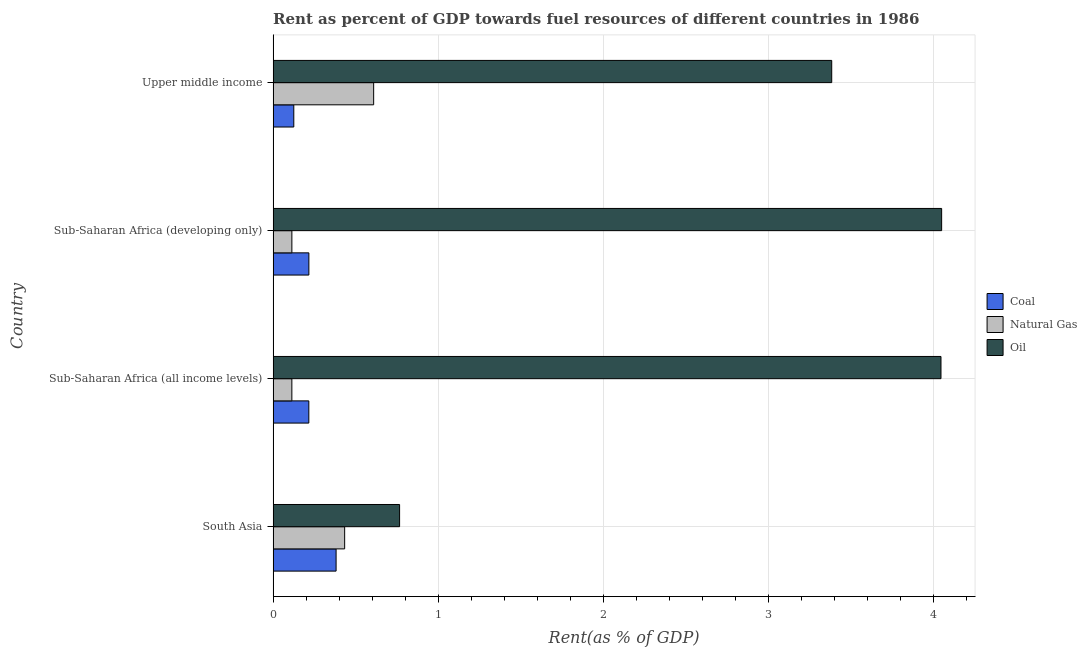How many different coloured bars are there?
Give a very brief answer. 3. Are the number of bars on each tick of the Y-axis equal?
Your answer should be compact. Yes. How many bars are there on the 1st tick from the top?
Your response must be concise. 3. How many bars are there on the 3rd tick from the bottom?
Provide a succinct answer. 3. What is the label of the 3rd group of bars from the top?
Your response must be concise. Sub-Saharan Africa (all income levels). In how many cases, is the number of bars for a given country not equal to the number of legend labels?
Keep it short and to the point. 0. What is the rent towards coal in Sub-Saharan Africa (all income levels)?
Keep it short and to the point. 0.22. Across all countries, what is the maximum rent towards coal?
Your answer should be compact. 0.38. Across all countries, what is the minimum rent towards oil?
Give a very brief answer. 0.77. In which country was the rent towards natural gas maximum?
Provide a succinct answer. Upper middle income. In which country was the rent towards oil minimum?
Provide a short and direct response. South Asia. What is the total rent towards oil in the graph?
Your answer should be very brief. 12.25. What is the difference between the rent towards oil in Sub-Saharan Africa (developing only) and that in Upper middle income?
Keep it short and to the point. 0.67. What is the difference between the rent towards natural gas in South Asia and the rent towards oil in Sub-Saharan Africa (all income levels)?
Provide a succinct answer. -3.61. What is the average rent towards coal per country?
Provide a short and direct response. 0.23. What is the difference between the rent towards natural gas and rent towards oil in Sub-Saharan Africa (all income levels)?
Your answer should be compact. -3.93. What is the ratio of the rent towards natural gas in South Asia to that in Upper middle income?
Your answer should be very brief. 0.71. Is the rent towards natural gas in South Asia less than that in Upper middle income?
Provide a succinct answer. Yes. What is the difference between the highest and the second highest rent towards oil?
Offer a terse response. 0. What is the difference between the highest and the lowest rent towards oil?
Offer a terse response. 3.28. What does the 3rd bar from the top in Sub-Saharan Africa (all income levels) represents?
Your response must be concise. Coal. What does the 2nd bar from the bottom in Sub-Saharan Africa (all income levels) represents?
Give a very brief answer. Natural Gas. How many bars are there?
Provide a short and direct response. 12. Are all the bars in the graph horizontal?
Keep it short and to the point. Yes. How many countries are there in the graph?
Keep it short and to the point. 4. What is the difference between two consecutive major ticks on the X-axis?
Give a very brief answer. 1. Does the graph contain grids?
Offer a terse response. Yes. Where does the legend appear in the graph?
Offer a very short reply. Center right. How are the legend labels stacked?
Give a very brief answer. Vertical. What is the title of the graph?
Ensure brevity in your answer.  Rent as percent of GDP towards fuel resources of different countries in 1986. What is the label or title of the X-axis?
Keep it short and to the point. Rent(as % of GDP). What is the Rent(as % of GDP) in Coal in South Asia?
Give a very brief answer. 0.38. What is the Rent(as % of GDP) of Natural Gas in South Asia?
Make the answer very short. 0.43. What is the Rent(as % of GDP) of Oil in South Asia?
Keep it short and to the point. 0.77. What is the Rent(as % of GDP) of Coal in Sub-Saharan Africa (all income levels)?
Offer a very short reply. 0.22. What is the Rent(as % of GDP) of Natural Gas in Sub-Saharan Africa (all income levels)?
Your response must be concise. 0.11. What is the Rent(as % of GDP) of Oil in Sub-Saharan Africa (all income levels)?
Ensure brevity in your answer.  4.05. What is the Rent(as % of GDP) of Coal in Sub-Saharan Africa (developing only)?
Offer a very short reply. 0.22. What is the Rent(as % of GDP) of Natural Gas in Sub-Saharan Africa (developing only)?
Offer a terse response. 0.11. What is the Rent(as % of GDP) of Oil in Sub-Saharan Africa (developing only)?
Give a very brief answer. 4.05. What is the Rent(as % of GDP) of Coal in Upper middle income?
Your answer should be compact. 0.13. What is the Rent(as % of GDP) of Natural Gas in Upper middle income?
Provide a short and direct response. 0.61. What is the Rent(as % of GDP) in Oil in Upper middle income?
Make the answer very short. 3.38. Across all countries, what is the maximum Rent(as % of GDP) in Coal?
Offer a terse response. 0.38. Across all countries, what is the maximum Rent(as % of GDP) of Natural Gas?
Your answer should be compact. 0.61. Across all countries, what is the maximum Rent(as % of GDP) of Oil?
Provide a succinct answer. 4.05. Across all countries, what is the minimum Rent(as % of GDP) in Coal?
Provide a succinct answer. 0.13. Across all countries, what is the minimum Rent(as % of GDP) of Natural Gas?
Your answer should be very brief. 0.11. Across all countries, what is the minimum Rent(as % of GDP) of Oil?
Give a very brief answer. 0.77. What is the total Rent(as % of GDP) in Coal in the graph?
Keep it short and to the point. 0.94. What is the total Rent(as % of GDP) in Natural Gas in the graph?
Give a very brief answer. 1.27. What is the total Rent(as % of GDP) in Oil in the graph?
Your answer should be compact. 12.25. What is the difference between the Rent(as % of GDP) in Coal in South Asia and that in Sub-Saharan Africa (all income levels)?
Provide a succinct answer. 0.17. What is the difference between the Rent(as % of GDP) of Natural Gas in South Asia and that in Sub-Saharan Africa (all income levels)?
Give a very brief answer. 0.32. What is the difference between the Rent(as % of GDP) of Oil in South Asia and that in Sub-Saharan Africa (all income levels)?
Keep it short and to the point. -3.28. What is the difference between the Rent(as % of GDP) of Coal in South Asia and that in Sub-Saharan Africa (developing only)?
Offer a very short reply. 0.17. What is the difference between the Rent(as % of GDP) of Natural Gas in South Asia and that in Sub-Saharan Africa (developing only)?
Keep it short and to the point. 0.32. What is the difference between the Rent(as % of GDP) of Oil in South Asia and that in Sub-Saharan Africa (developing only)?
Keep it short and to the point. -3.28. What is the difference between the Rent(as % of GDP) in Coal in South Asia and that in Upper middle income?
Give a very brief answer. 0.26. What is the difference between the Rent(as % of GDP) of Natural Gas in South Asia and that in Upper middle income?
Your answer should be very brief. -0.18. What is the difference between the Rent(as % of GDP) of Oil in South Asia and that in Upper middle income?
Your answer should be very brief. -2.62. What is the difference between the Rent(as % of GDP) in Coal in Sub-Saharan Africa (all income levels) and that in Sub-Saharan Africa (developing only)?
Ensure brevity in your answer.  -0. What is the difference between the Rent(as % of GDP) in Natural Gas in Sub-Saharan Africa (all income levels) and that in Sub-Saharan Africa (developing only)?
Give a very brief answer. -0. What is the difference between the Rent(as % of GDP) of Oil in Sub-Saharan Africa (all income levels) and that in Sub-Saharan Africa (developing only)?
Give a very brief answer. -0. What is the difference between the Rent(as % of GDP) in Coal in Sub-Saharan Africa (all income levels) and that in Upper middle income?
Your response must be concise. 0.09. What is the difference between the Rent(as % of GDP) of Natural Gas in Sub-Saharan Africa (all income levels) and that in Upper middle income?
Ensure brevity in your answer.  -0.5. What is the difference between the Rent(as % of GDP) in Oil in Sub-Saharan Africa (all income levels) and that in Upper middle income?
Offer a very short reply. 0.66. What is the difference between the Rent(as % of GDP) in Coal in Sub-Saharan Africa (developing only) and that in Upper middle income?
Keep it short and to the point. 0.09. What is the difference between the Rent(as % of GDP) of Natural Gas in Sub-Saharan Africa (developing only) and that in Upper middle income?
Keep it short and to the point. -0.5. What is the difference between the Rent(as % of GDP) in Oil in Sub-Saharan Africa (developing only) and that in Upper middle income?
Give a very brief answer. 0.67. What is the difference between the Rent(as % of GDP) in Coal in South Asia and the Rent(as % of GDP) in Natural Gas in Sub-Saharan Africa (all income levels)?
Make the answer very short. 0.27. What is the difference between the Rent(as % of GDP) of Coal in South Asia and the Rent(as % of GDP) of Oil in Sub-Saharan Africa (all income levels)?
Offer a very short reply. -3.66. What is the difference between the Rent(as % of GDP) of Natural Gas in South Asia and the Rent(as % of GDP) of Oil in Sub-Saharan Africa (all income levels)?
Your response must be concise. -3.61. What is the difference between the Rent(as % of GDP) in Coal in South Asia and the Rent(as % of GDP) in Natural Gas in Sub-Saharan Africa (developing only)?
Provide a short and direct response. 0.27. What is the difference between the Rent(as % of GDP) in Coal in South Asia and the Rent(as % of GDP) in Oil in Sub-Saharan Africa (developing only)?
Offer a terse response. -3.67. What is the difference between the Rent(as % of GDP) of Natural Gas in South Asia and the Rent(as % of GDP) of Oil in Sub-Saharan Africa (developing only)?
Provide a succinct answer. -3.62. What is the difference between the Rent(as % of GDP) in Coal in South Asia and the Rent(as % of GDP) in Natural Gas in Upper middle income?
Make the answer very short. -0.23. What is the difference between the Rent(as % of GDP) in Coal in South Asia and the Rent(as % of GDP) in Oil in Upper middle income?
Keep it short and to the point. -3. What is the difference between the Rent(as % of GDP) in Natural Gas in South Asia and the Rent(as % of GDP) in Oil in Upper middle income?
Offer a terse response. -2.95. What is the difference between the Rent(as % of GDP) of Coal in Sub-Saharan Africa (all income levels) and the Rent(as % of GDP) of Natural Gas in Sub-Saharan Africa (developing only)?
Provide a succinct answer. 0.1. What is the difference between the Rent(as % of GDP) in Coal in Sub-Saharan Africa (all income levels) and the Rent(as % of GDP) in Oil in Sub-Saharan Africa (developing only)?
Your answer should be very brief. -3.83. What is the difference between the Rent(as % of GDP) in Natural Gas in Sub-Saharan Africa (all income levels) and the Rent(as % of GDP) in Oil in Sub-Saharan Africa (developing only)?
Ensure brevity in your answer.  -3.94. What is the difference between the Rent(as % of GDP) of Coal in Sub-Saharan Africa (all income levels) and the Rent(as % of GDP) of Natural Gas in Upper middle income?
Provide a short and direct response. -0.39. What is the difference between the Rent(as % of GDP) in Coal in Sub-Saharan Africa (all income levels) and the Rent(as % of GDP) in Oil in Upper middle income?
Offer a very short reply. -3.17. What is the difference between the Rent(as % of GDP) of Natural Gas in Sub-Saharan Africa (all income levels) and the Rent(as % of GDP) of Oil in Upper middle income?
Your response must be concise. -3.27. What is the difference between the Rent(as % of GDP) in Coal in Sub-Saharan Africa (developing only) and the Rent(as % of GDP) in Natural Gas in Upper middle income?
Provide a succinct answer. -0.39. What is the difference between the Rent(as % of GDP) of Coal in Sub-Saharan Africa (developing only) and the Rent(as % of GDP) of Oil in Upper middle income?
Provide a short and direct response. -3.17. What is the difference between the Rent(as % of GDP) of Natural Gas in Sub-Saharan Africa (developing only) and the Rent(as % of GDP) of Oil in Upper middle income?
Make the answer very short. -3.27. What is the average Rent(as % of GDP) of Coal per country?
Make the answer very short. 0.23. What is the average Rent(as % of GDP) of Natural Gas per country?
Your answer should be compact. 0.32. What is the average Rent(as % of GDP) in Oil per country?
Offer a very short reply. 3.06. What is the difference between the Rent(as % of GDP) in Coal and Rent(as % of GDP) in Natural Gas in South Asia?
Offer a terse response. -0.05. What is the difference between the Rent(as % of GDP) of Coal and Rent(as % of GDP) of Oil in South Asia?
Ensure brevity in your answer.  -0.38. What is the difference between the Rent(as % of GDP) in Natural Gas and Rent(as % of GDP) in Oil in South Asia?
Your answer should be very brief. -0.33. What is the difference between the Rent(as % of GDP) in Coal and Rent(as % of GDP) in Natural Gas in Sub-Saharan Africa (all income levels)?
Ensure brevity in your answer.  0.1. What is the difference between the Rent(as % of GDP) of Coal and Rent(as % of GDP) of Oil in Sub-Saharan Africa (all income levels)?
Offer a very short reply. -3.83. What is the difference between the Rent(as % of GDP) in Natural Gas and Rent(as % of GDP) in Oil in Sub-Saharan Africa (all income levels)?
Provide a succinct answer. -3.93. What is the difference between the Rent(as % of GDP) in Coal and Rent(as % of GDP) in Natural Gas in Sub-Saharan Africa (developing only)?
Make the answer very short. 0.1. What is the difference between the Rent(as % of GDP) in Coal and Rent(as % of GDP) in Oil in Sub-Saharan Africa (developing only)?
Ensure brevity in your answer.  -3.83. What is the difference between the Rent(as % of GDP) in Natural Gas and Rent(as % of GDP) in Oil in Sub-Saharan Africa (developing only)?
Your answer should be very brief. -3.94. What is the difference between the Rent(as % of GDP) of Coal and Rent(as % of GDP) of Natural Gas in Upper middle income?
Ensure brevity in your answer.  -0.48. What is the difference between the Rent(as % of GDP) of Coal and Rent(as % of GDP) of Oil in Upper middle income?
Offer a terse response. -3.26. What is the difference between the Rent(as % of GDP) in Natural Gas and Rent(as % of GDP) in Oil in Upper middle income?
Give a very brief answer. -2.77. What is the ratio of the Rent(as % of GDP) of Coal in South Asia to that in Sub-Saharan Africa (all income levels)?
Give a very brief answer. 1.76. What is the ratio of the Rent(as % of GDP) in Natural Gas in South Asia to that in Sub-Saharan Africa (all income levels)?
Make the answer very short. 3.82. What is the ratio of the Rent(as % of GDP) of Oil in South Asia to that in Sub-Saharan Africa (all income levels)?
Ensure brevity in your answer.  0.19. What is the ratio of the Rent(as % of GDP) of Coal in South Asia to that in Sub-Saharan Africa (developing only)?
Your response must be concise. 1.76. What is the ratio of the Rent(as % of GDP) of Natural Gas in South Asia to that in Sub-Saharan Africa (developing only)?
Provide a short and direct response. 3.81. What is the ratio of the Rent(as % of GDP) in Oil in South Asia to that in Sub-Saharan Africa (developing only)?
Your answer should be very brief. 0.19. What is the ratio of the Rent(as % of GDP) of Coal in South Asia to that in Upper middle income?
Ensure brevity in your answer.  3.05. What is the ratio of the Rent(as % of GDP) of Natural Gas in South Asia to that in Upper middle income?
Offer a terse response. 0.71. What is the ratio of the Rent(as % of GDP) of Oil in South Asia to that in Upper middle income?
Offer a very short reply. 0.23. What is the ratio of the Rent(as % of GDP) of Coal in Sub-Saharan Africa (all income levels) to that in Sub-Saharan Africa (developing only)?
Your answer should be compact. 1. What is the ratio of the Rent(as % of GDP) of Natural Gas in Sub-Saharan Africa (all income levels) to that in Sub-Saharan Africa (developing only)?
Your response must be concise. 1. What is the ratio of the Rent(as % of GDP) of Coal in Sub-Saharan Africa (all income levels) to that in Upper middle income?
Ensure brevity in your answer.  1.73. What is the ratio of the Rent(as % of GDP) in Natural Gas in Sub-Saharan Africa (all income levels) to that in Upper middle income?
Your answer should be very brief. 0.19. What is the ratio of the Rent(as % of GDP) of Oil in Sub-Saharan Africa (all income levels) to that in Upper middle income?
Offer a terse response. 1.2. What is the ratio of the Rent(as % of GDP) in Coal in Sub-Saharan Africa (developing only) to that in Upper middle income?
Keep it short and to the point. 1.73. What is the ratio of the Rent(as % of GDP) of Natural Gas in Sub-Saharan Africa (developing only) to that in Upper middle income?
Give a very brief answer. 0.19. What is the ratio of the Rent(as % of GDP) in Oil in Sub-Saharan Africa (developing only) to that in Upper middle income?
Offer a terse response. 1.2. What is the difference between the highest and the second highest Rent(as % of GDP) of Coal?
Ensure brevity in your answer.  0.17. What is the difference between the highest and the second highest Rent(as % of GDP) of Natural Gas?
Give a very brief answer. 0.18. What is the difference between the highest and the second highest Rent(as % of GDP) of Oil?
Ensure brevity in your answer.  0. What is the difference between the highest and the lowest Rent(as % of GDP) of Coal?
Offer a very short reply. 0.26. What is the difference between the highest and the lowest Rent(as % of GDP) of Natural Gas?
Your answer should be compact. 0.5. What is the difference between the highest and the lowest Rent(as % of GDP) in Oil?
Make the answer very short. 3.28. 